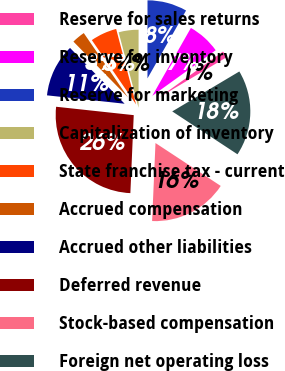Convert chart to OTSL. <chart><loc_0><loc_0><loc_500><loc_500><pie_chart><fcel>Reserve for sales returns<fcel>Reserve for inventory<fcel>Reserve for marketing<fcel>Capitalization of inventory<fcel>State franchise tax - current<fcel>Accrued compensation<fcel>Accrued other liabilities<fcel>Deferred revenue<fcel>Stock-based compensation<fcel>Foreign net operating loss<nl><fcel>1.37%<fcel>6.85%<fcel>8.22%<fcel>4.11%<fcel>5.48%<fcel>2.74%<fcel>10.96%<fcel>26.02%<fcel>16.43%<fcel>17.8%<nl></chart> 